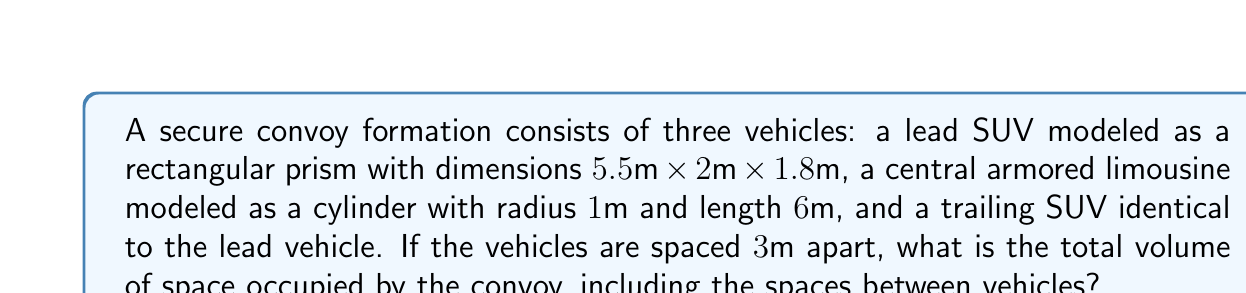Give your solution to this math problem. Let's approach this step-by-step:

1) First, calculate the volume of each SUV:
   $$V_{SUV} = l \times w \times h = 5.5 \times 2 \times 1.8 = 19.8 \text{ m}^3$$

2) Calculate the volume of the limousine:
   $$V_{limo} = \pi r^2 h = \pi \times 1^2 \times 6 = 6\pi \text{ m}^3$$

3) The total length of the convoy:
   $$L_{total} = 2L_{SUV} + L_{limo} + 2 \times \text{spacing}$$
   $$L_{total} = (2 \times 5.5) + 6 + (2 \times 3) = 23 \text{ m}$$

4) The width and height of the convoy will be the maximum of all vehicles:
   $$W_{convoy} = 2 \text{ m}$$
   $$H_{convoy} = 1.8 \text{ m}$$

5) Calculate the total volume of the convoy formation:
   $$V_{total} = L_{total} \times W_{convoy} \times H_{convoy}$$
   $$V_{total} = 23 \times 2 \times 1.8 = 82.8 \text{ m}^3$$

6) The actual volume occupied by vehicles:
   $$V_{vehicles} = 2V_{SUV} + V_{limo} = (2 \times 19.8) + 6\pi = 39.6 + 6\pi \text{ m}^3$$

7) The difference between these volumes is the space between and around vehicles:
   $$V_{space} = V_{total} - V_{vehicles} = 82.8 - (39.6 + 6\pi) = 43.2 - 6\pi \text{ m}^3$$

Therefore, the total volume of space occupied by the convoy, including spaces between vehicles, is 82.8 m³.
Answer: 82.8 m³ 